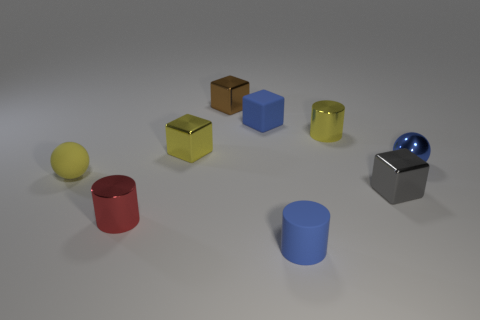Subtract 1 cubes. How many cubes are left? 3 Add 1 large green cubes. How many objects exist? 10 Subtract all blocks. How many objects are left? 5 Add 1 tiny blue objects. How many tiny blue objects are left? 4 Add 5 small blue objects. How many small blue objects exist? 8 Subtract 0 green balls. How many objects are left? 9 Subtract all red metal cylinders. Subtract all brown metallic cubes. How many objects are left? 7 